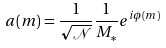<formula> <loc_0><loc_0><loc_500><loc_500>a ( m ) = \frac { 1 } { \sqrt { \mathcal { N } } } \frac { 1 } { M _ { \ast } } e ^ { i \phi ( m ) }</formula> 